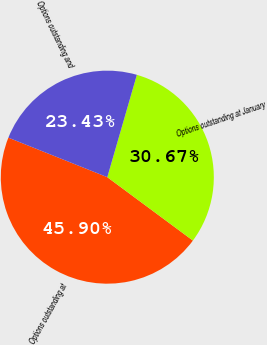Convert chart. <chart><loc_0><loc_0><loc_500><loc_500><pie_chart><fcel>Options outstanding at<fcel>Options outstanding at January<fcel>Options outstanding and<nl><fcel>45.9%<fcel>30.67%<fcel>23.43%<nl></chart> 